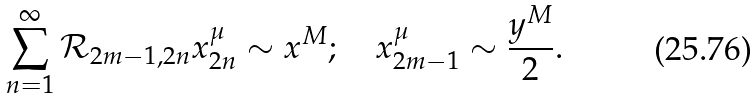Convert formula to latex. <formula><loc_0><loc_0><loc_500><loc_500>\sum _ { n = 1 } ^ { \infty } \mathcal { R } _ { 2 m - 1 , 2 n } x _ { 2 n } ^ { \mu } \sim x ^ { M } ; \quad x _ { 2 m - 1 } ^ { \mu } \sim \frac { y ^ { M } } { 2 } .</formula> 